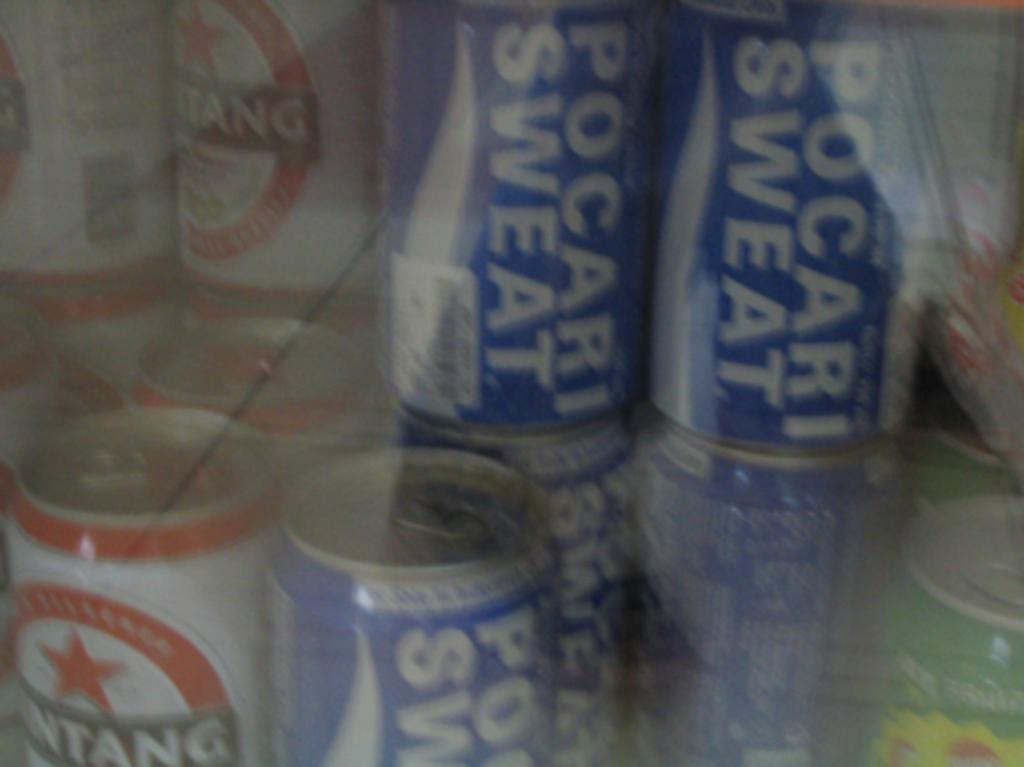Provide a one-sentence caption for the provided image. Blurry image of pocari sweat and some other canned beverages. 